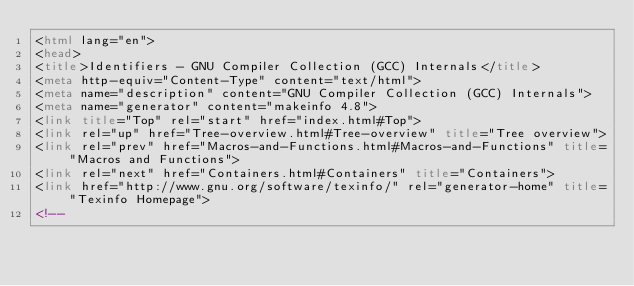Convert code to text. <code><loc_0><loc_0><loc_500><loc_500><_HTML_><html lang="en">
<head>
<title>Identifiers - GNU Compiler Collection (GCC) Internals</title>
<meta http-equiv="Content-Type" content="text/html">
<meta name="description" content="GNU Compiler Collection (GCC) Internals">
<meta name="generator" content="makeinfo 4.8">
<link title="Top" rel="start" href="index.html#Top">
<link rel="up" href="Tree-overview.html#Tree-overview" title="Tree overview">
<link rel="prev" href="Macros-and-Functions.html#Macros-and-Functions" title="Macros and Functions">
<link rel="next" href="Containers.html#Containers" title="Containers">
<link href="http://www.gnu.org/software/texinfo/" rel="generator-home" title="Texinfo Homepage">
<!--</code> 